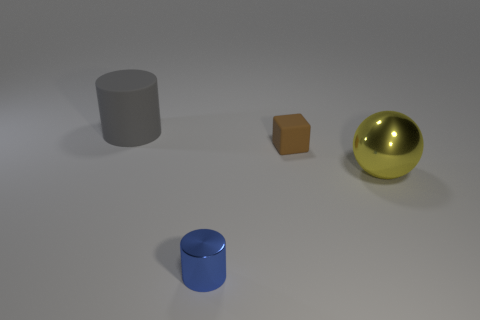Subtract 0 gray blocks. How many objects are left? 4 Subtract all balls. How many objects are left? 3 Subtract 2 cylinders. How many cylinders are left? 0 Subtract all purple cylinders. Subtract all blue balls. How many cylinders are left? 2 Subtract all brown cylinders. How many brown spheres are left? 0 Subtract all big red shiny cubes. Subtract all large shiny objects. How many objects are left? 3 Add 1 large gray matte cylinders. How many large gray matte cylinders are left? 2 Add 4 brown rubber things. How many brown rubber things exist? 5 Add 3 yellow spheres. How many objects exist? 7 